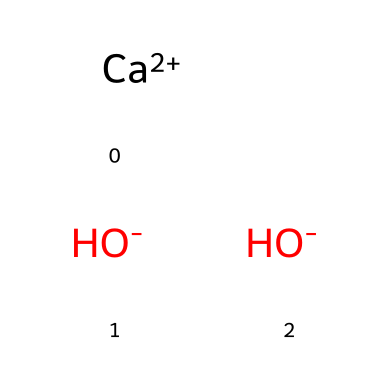What is the chemical name of this compound? The SMILES representation indicates that the compound contains calcium ions and hydroxide ions. The combination of these components is known as calcium hydroxide.
Answer: calcium hydroxide How many hydroxide ions are present in this chemical? The SMILES notation shows two hydroxide ions, represented by the two [OH-] in the structure.
Answer: two What is the charge of the calcium ion? The notation [Ca+2] indicates that the calcium ion has a charge of +2. Therefore, it is twice positively charged.
Answer: +2 What type of compound is calcium hydroxide? Calcium hydroxide is classified as a base because it contains hydroxide ions that can increase the pH of a solution.
Answer: base Why is calcium hydroxide used in antacids? Calcium hydroxide neutralizes stomach acid, which reduces acidity and relieves heartburn or indigestion, leading to its use in antacids.
Answer: neutralizes acid What general characteristic of bases does calcium hydroxide exemplify? Calcium hydroxide exemplifies the characteristic of bases to have a bitter taste and a slippery feel, which are common traits of base substances.
Answer: bitter taste and slippery feel 